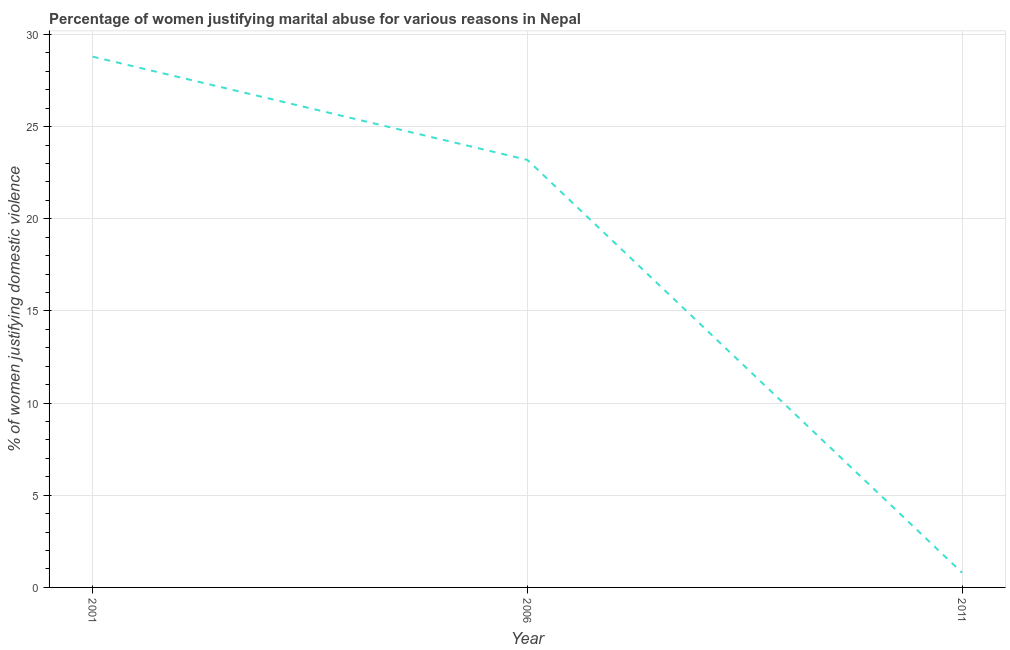Across all years, what is the maximum percentage of women justifying marital abuse?
Provide a succinct answer. 28.8. In which year was the percentage of women justifying marital abuse maximum?
Offer a very short reply. 2001. In which year was the percentage of women justifying marital abuse minimum?
Offer a terse response. 2011. What is the sum of the percentage of women justifying marital abuse?
Make the answer very short. 52.8. What is the difference between the percentage of women justifying marital abuse in 2001 and 2006?
Ensure brevity in your answer.  5.6. What is the average percentage of women justifying marital abuse per year?
Make the answer very short. 17.6. What is the median percentage of women justifying marital abuse?
Give a very brief answer. 23.2. Do a majority of the years between 2001 and 2011 (inclusive) have percentage of women justifying marital abuse greater than 3 %?
Make the answer very short. Yes. What is the ratio of the percentage of women justifying marital abuse in 2006 to that in 2011?
Ensure brevity in your answer.  29. Is the percentage of women justifying marital abuse in 2001 less than that in 2006?
Provide a short and direct response. No. What is the difference between the highest and the second highest percentage of women justifying marital abuse?
Make the answer very short. 5.6. Is the sum of the percentage of women justifying marital abuse in 2001 and 2006 greater than the maximum percentage of women justifying marital abuse across all years?
Offer a terse response. Yes. What is the difference between the highest and the lowest percentage of women justifying marital abuse?
Your response must be concise. 28. In how many years, is the percentage of women justifying marital abuse greater than the average percentage of women justifying marital abuse taken over all years?
Offer a very short reply. 2. Does the percentage of women justifying marital abuse monotonically increase over the years?
Provide a succinct answer. No. How many lines are there?
Ensure brevity in your answer.  1. Are the values on the major ticks of Y-axis written in scientific E-notation?
Make the answer very short. No. Does the graph contain grids?
Keep it short and to the point. Yes. What is the title of the graph?
Provide a short and direct response. Percentage of women justifying marital abuse for various reasons in Nepal. What is the label or title of the Y-axis?
Ensure brevity in your answer.  % of women justifying domestic violence. What is the % of women justifying domestic violence in 2001?
Make the answer very short. 28.8. What is the % of women justifying domestic violence in 2006?
Make the answer very short. 23.2. What is the difference between the % of women justifying domestic violence in 2001 and 2006?
Provide a short and direct response. 5.6. What is the difference between the % of women justifying domestic violence in 2006 and 2011?
Provide a succinct answer. 22.4. What is the ratio of the % of women justifying domestic violence in 2001 to that in 2006?
Your response must be concise. 1.24. What is the ratio of the % of women justifying domestic violence in 2001 to that in 2011?
Make the answer very short. 36. 